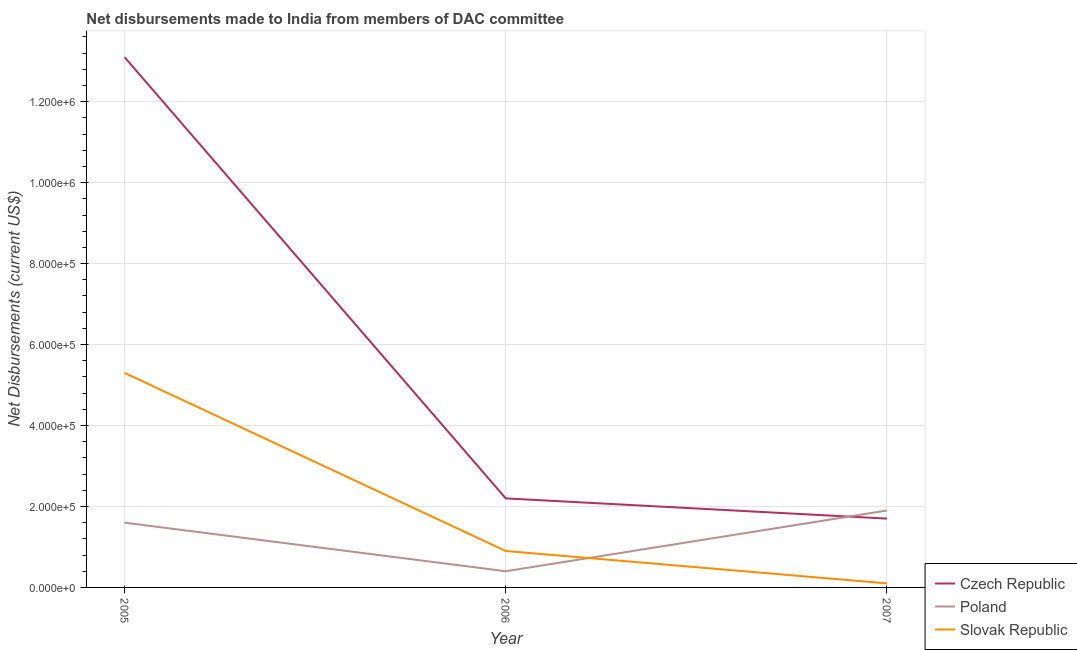Is the number of lines equal to the number of legend labels?
Give a very brief answer. Yes. What is the net disbursements made by czech republic in 2005?
Ensure brevity in your answer.  1.31e+06. Across all years, what is the maximum net disbursements made by slovak republic?
Offer a terse response. 5.30e+05. Across all years, what is the minimum net disbursements made by slovak republic?
Provide a short and direct response. 10000. In which year was the net disbursements made by czech republic maximum?
Your answer should be very brief. 2005. In which year was the net disbursements made by slovak republic minimum?
Your answer should be very brief. 2007. What is the total net disbursements made by slovak republic in the graph?
Offer a terse response. 6.30e+05. What is the difference between the net disbursements made by poland in 2005 and that in 2007?
Provide a succinct answer. -3.00e+04. What is the difference between the net disbursements made by slovak republic in 2007 and the net disbursements made by poland in 2005?
Make the answer very short. -1.50e+05. What is the average net disbursements made by slovak republic per year?
Your answer should be compact. 2.10e+05. In the year 2005, what is the difference between the net disbursements made by poland and net disbursements made by slovak republic?
Give a very brief answer. -3.70e+05. What is the ratio of the net disbursements made by czech republic in 2006 to that in 2007?
Provide a succinct answer. 1.29. Is the net disbursements made by slovak republic in 2005 less than that in 2007?
Make the answer very short. No. What is the difference between the highest and the second highest net disbursements made by czech republic?
Keep it short and to the point. 1.09e+06. What is the difference between the highest and the lowest net disbursements made by poland?
Offer a terse response. 1.50e+05. Is the net disbursements made by poland strictly greater than the net disbursements made by slovak republic over the years?
Provide a succinct answer. No. How many years are there in the graph?
Provide a succinct answer. 3. What is the difference between two consecutive major ticks on the Y-axis?
Your response must be concise. 2.00e+05. Are the values on the major ticks of Y-axis written in scientific E-notation?
Give a very brief answer. Yes. Does the graph contain any zero values?
Offer a very short reply. No. How many legend labels are there?
Your answer should be very brief. 3. What is the title of the graph?
Offer a very short reply. Net disbursements made to India from members of DAC committee. What is the label or title of the Y-axis?
Ensure brevity in your answer.  Net Disbursements (current US$). What is the Net Disbursements (current US$) in Czech Republic in 2005?
Your answer should be very brief. 1.31e+06. What is the Net Disbursements (current US$) in Slovak Republic in 2005?
Your answer should be very brief. 5.30e+05. What is the Net Disbursements (current US$) of Poland in 2006?
Give a very brief answer. 4.00e+04. Across all years, what is the maximum Net Disbursements (current US$) of Czech Republic?
Offer a terse response. 1.31e+06. Across all years, what is the maximum Net Disbursements (current US$) of Poland?
Your response must be concise. 1.90e+05. Across all years, what is the maximum Net Disbursements (current US$) of Slovak Republic?
Your answer should be very brief. 5.30e+05. Across all years, what is the minimum Net Disbursements (current US$) of Czech Republic?
Offer a terse response. 1.70e+05. Across all years, what is the minimum Net Disbursements (current US$) in Slovak Republic?
Keep it short and to the point. 10000. What is the total Net Disbursements (current US$) in Czech Republic in the graph?
Your response must be concise. 1.70e+06. What is the total Net Disbursements (current US$) of Poland in the graph?
Offer a terse response. 3.90e+05. What is the total Net Disbursements (current US$) in Slovak Republic in the graph?
Offer a very short reply. 6.30e+05. What is the difference between the Net Disbursements (current US$) of Czech Republic in 2005 and that in 2006?
Ensure brevity in your answer.  1.09e+06. What is the difference between the Net Disbursements (current US$) of Slovak Republic in 2005 and that in 2006?
Provide a short and direct response. 4.40e+05. What is the difference between the Net Disbursements (current US$) in Czech Republic in 2005 and that in 2007?
Ensure brevity in your answer.  1.14e+06. What is the difference between the Net Disbursements (current US$) of Poland in 2005 and that in 2007?
Provide a succinct answer. -3.00e+04. What is the difference between the Net Disbursements (current US$) in Slovak Republic in 2005 and that in 2007?
Give a very brief answer. 5.20e+05. What is the difference between the Net Disbursements (current US$) of Czech Republic in 2006 and that in 2007?
Give a very brief answer. 5.00e+04. What is the difference between the Net Disbursements (current US$) of Poland in 2006 and that in 2007?
Offer a terse response. -1.50e+05. What is the difference between the Net Disbursements (current US$) in Slovak Republic in 2006 and that in 2007?
Give a very brief answer. 8.00e+04. What is the difference between the Net Disbursements (current US$) of Czech Republic in 2005 and the Net Disbursements (current US$) of Poland in 2006?
Your answer should be compact. 1.27e+06. What is the difference between the Net Disbursements (current US$) of Czech Republic in 2005 and the Net Disbursements (current US$) of Slovak Republic in 2006?
Keep it short and to the point. 1.22e+06. What is the difference between the Net Disbursements (current US$) of Czech Republic in 2005 and the Net Disbursements (current US$) of Poland in 2007?
Your answer should be very brief. 1.12e+06. What is the difference between the Net Disbursements (current US$) in Czech Republic in 2005 and the Net Disbursements (current US$) in Slovak Republic in 2007?
Give a very brief answer. 1.30e+06. What is the difference between the Net Disbursements (current US$) of Poland in 2006 and the Net Disbursements (current US$) of Slovak Republic in 2007?
Your response must be concise. 3.00e+04. What is the average Net Disbursements (current US$) in Czech Republic per year?
Offer a very short reply. 5.67e+05. What is the average Net Disbursements (current US$) in Poland per year?
Give a very brief answer. 1.30e+05. What is the average Net Disbursements (current US$) in Slovak Republic per year?
Give a very brief answer. 2.10e+05. In the year 2005, what is the difference between the Net Disbursements (current US$) of Czech Republic and Net Disbursements (current US$) of Poland?
Provide a succinct answer. 1.15e+06. In the year 2005, what is the difference between the Net Disbursements (current US$) of Czech Republic and Net Disbursements (current US$) of Slovak Republic?
Ensure brevity in your answer.  7.80e+05. In the year 2005, what is the difference between the Net Disbursements (current US$) in Poland and Net Disbursements (current US$) in Slovak Republic?
Your answer should be compact. -3.70e+05. In the year 2006, what is the difference between the Net Disbursements (current US$) in Poland and Net Disbursements (current US$) in Slovak Republic?
Offer a terse response. -5.00e+04. In the year 2007, what is the difference between the Net Disbursements (current US$) in Czech Republic and Net Disbursements (current US$) in Poland?
Make the answer very short. -2.00e+04. In the year 2007, what is the difference between the Net Disbursements (current US$) in Poland and Net Disbursements (current US$) in Slovak Republic?
Ensure brevity in your answer.  1.80e+05. What is the ratio of the Net Disbursements (current US$) of Czech Republic in 2005 to that in 2006?
Your answer should be very brief. 5.95. What is the ratio of the Net Disbursements (current US$) of Poland in 2005 to that in 2006?
Your answer should be compact. 4. What is the ratio of the Net Disbursements (current US$) in Slovak Republic in 2005 to that in 2006?
Make the answer very short. 5.89. What is the ratio of the Net Disbursements (current US$) of Czech Republic in 2005 to that in 2007?
Keep it short and to the point. 7.71. What is the ratio of the Net Disbursements (current US$) of Poland in 2005 to that in 2007?
Ensure brevity in your answer.  0.84. What is the ratio of the Net Disbursements (current US$) in Czech Republic in 2006 to that in 2007?
Your answer should be compact. 1.29. What is the ratio of the Net Disbursements (current US$) of Poland in 2006 to that in 2007?
Give a very brief answer. 0.21. What is the difference between the highest and the second highest Net Disbursements (current US$) in Czech Republic?
Provide a short and direct response. 1.09e+06. What is the difference between the highest and the second highest Net Disbursements (current US$) in Poland?
Provide a succinct answer. 3.00e+04. What is the difference between the highest and the second highest Net Disbursements (current US$) in Slovak Republic?
Provide a succinct answer. 4.40e+05. What is the difference between the highest and the lowest Net Disbursements (current US$) in Czech Republic?
Your response must be concise. 1.14e+06. What is the difference between the highest and the lowest Net Disbursements (current US$) in Poland?
Make the answer very short. 1.50e+05. What is the difference between the highest and the lowest Net Disbursements (current US$) in Slovak Republic?
Offer a very short reply. 5.20e+05. 